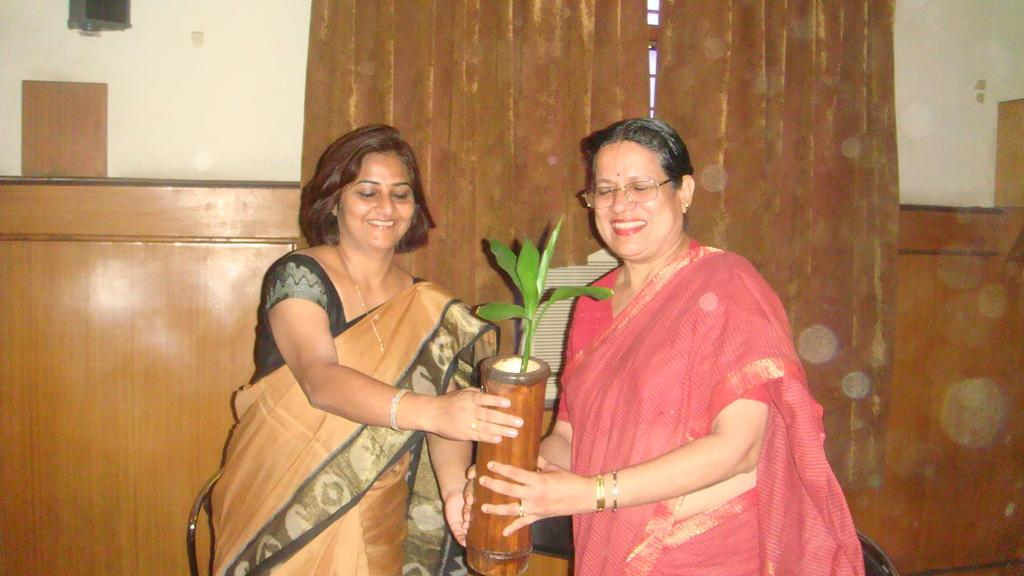How many women are in the image? There are two women in the foreground of the image. What are the women holding in the image? The women are holding a flower pot. What is on the flower pot? There is a plant on the flower pot. What can be seen in the background of the image? There is a wall, a curtain, and a wooden object in the background of the image. How many eggs are visible in the image? There are no eggs present in the image. Can you tell me what type of airport is in the background of the image? There is no airport present in the image; it features a wall, a curtain, and a wooden object in the background. 